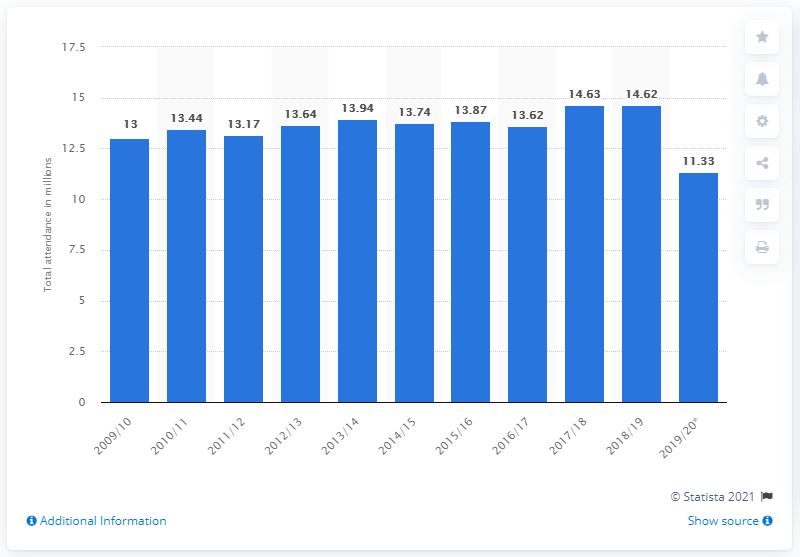Mention a couple of crucial points in this snapshot. The total attendance at games in the 2019/20 season was 11,330. 